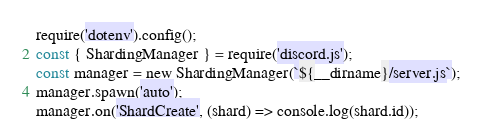<code> <loc_0><loc_0><loc_500><loc_500><_JavaScript_>require('dotenv').config();
const { ShardingManager } = require('discord.js');
const manager = new ShardingManager(`${__dirname}/server.js`);
manager.spawn('auto');
manager.on('ShardCreate', (shard) => console.log(shard.id));</code> 